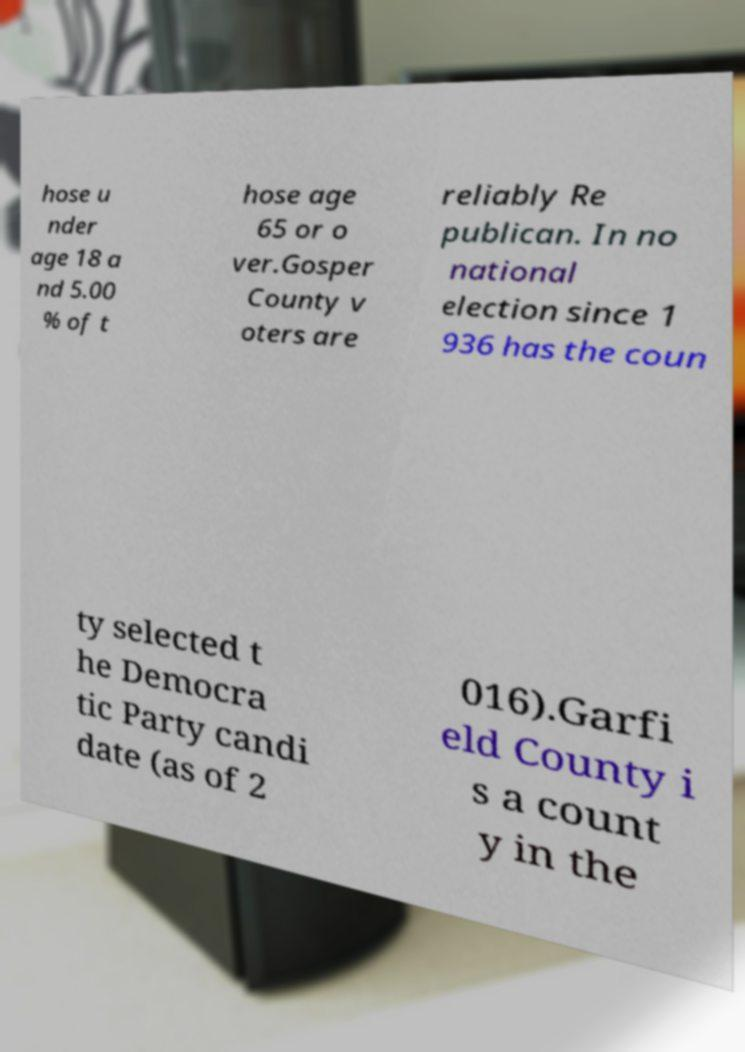Can you accurately transcribe the text from the provided image for me? hose u nder age 18 a nd 5.00 % of t hose age 65 or o ver.Gosper County v oters are reliably Re publican. In no national election since 1 936 has the coun ty selected t he Democra tic Party candi date (as of 2 016).Garfi eld County i s a count y in the 